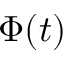Convert formula to latex. <formula><loc_0><loc_0><loc_500><loc_500>\Phi ( t )</formula> 